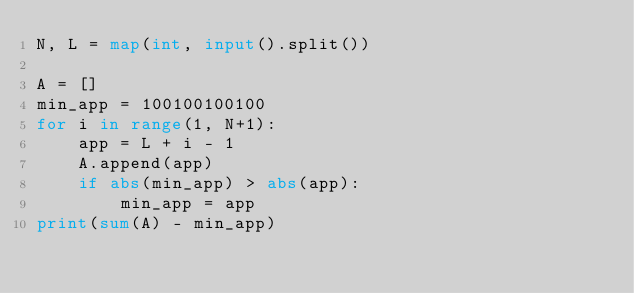Convert code to text. <code><loc_0><loc_0><loc_500><loc_500><_Python_>N, L = map(int, input().split())

A = []
min_app = 100100100100
for i in range(1, N+1):
    app = L + i - 1
    A.append(app)
    if abs(min_app) > abs(app):
        min_app = app
print(sum(A) - min_app)</code> 